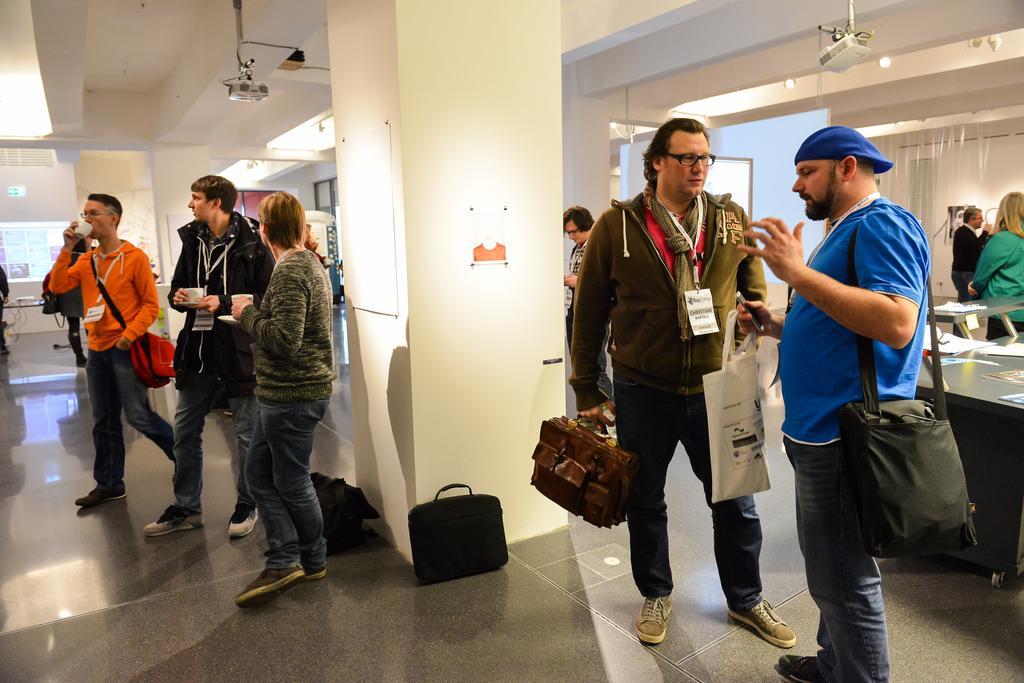How would you summarize this image in a sentence or two? In this image there are a few people standing and some are walking on the floor. In them few are holding bags, cups and some other objects in their hand, on the right side of the image there is a table and a few objects on it. At the top there is a ceiling with lights and projectors. 